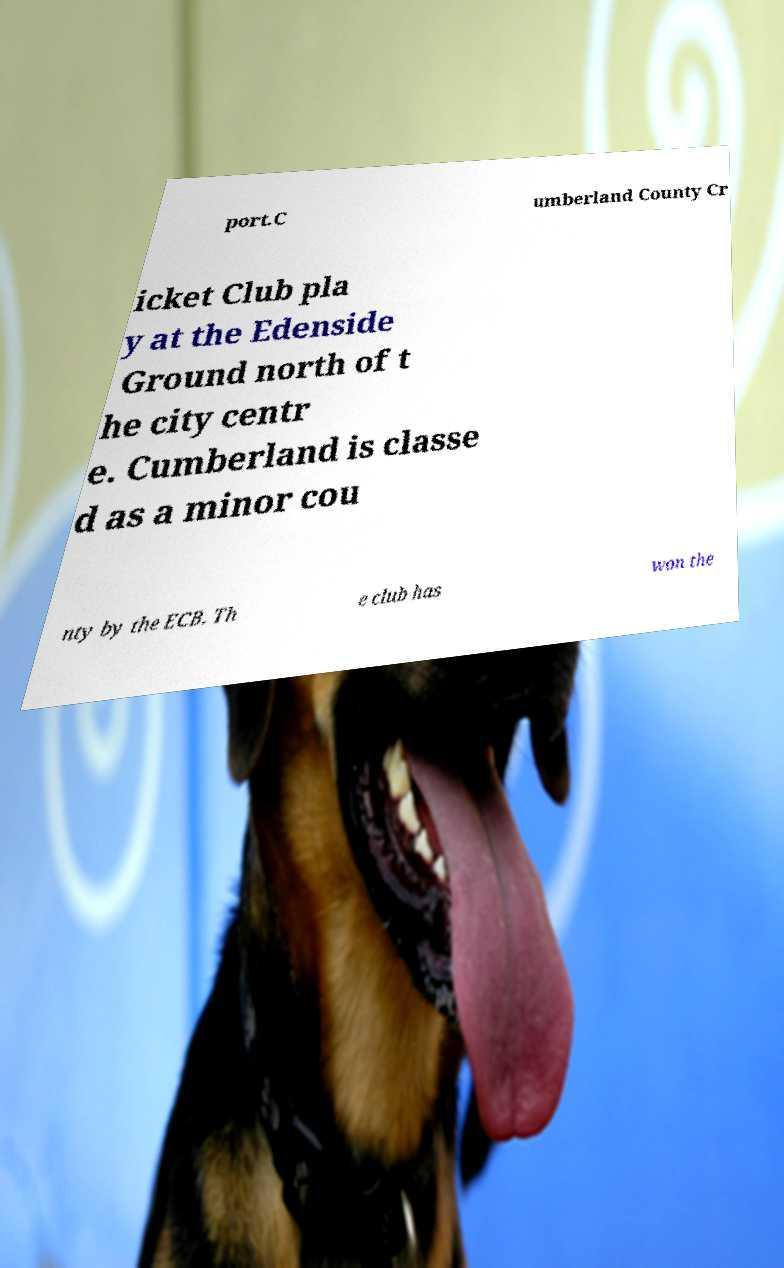What messages or text are displayed in this image? I need them in a readable, typed format. port.C umberland County Cr icket Club pla y at the Edenside Ground north of t he city centr e. Cumberland is classe d as a minor cou nty by the ECB. Th e club has won the 